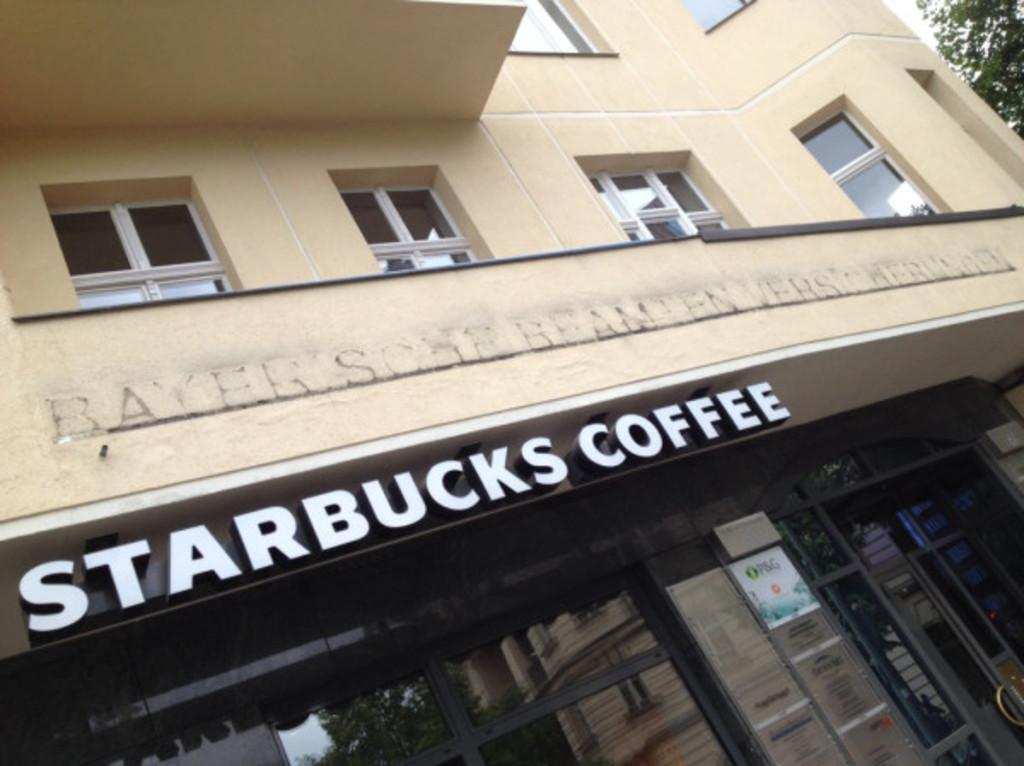What type of structure is present in the image? There is a building in the image. What features can be seen on the building? The building has windows and doors. Are there any decorations or signs on the building? Yes, there are posters on the building and text visible on it. What can be seen on the right side of the image? There are trees on the right side of the image. What is visible in the background of the image? The sky is visible in the image. What type of linen is being used to cover the windows in the image? There is no mention of linen or any window coverings in the image; the building has windows, but their state is not described. 